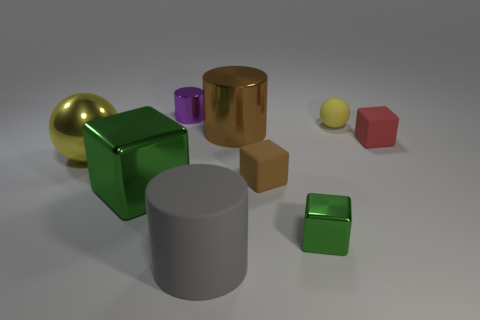Do the red cube and the big gray object have the same material?
Offer a terse response. Yes. What material is the block that is to the right of the yellow sphere that is to the right of the big cylinder that is behind the big gray rubber object made of?
Offer a terse response. Rubber. What color is the large rubber cylinder?
Keep it short and to the point. Gray. How many large things are gray things or red objects?
Offer a terse response. 1. There is a small cube that is the same color as the big cube; what is it made of?
Your answer should be very brief. Metal. Do the green object to the right of the purple metal thing and the red object right of the big gray object have the same material?
Keep it short and to the point. No. Are there any red matte blocks?
Make the answer very short. Yes. Are there more big gray cylinders that are to the left of the small red cube than small brown matte things that are behind the yellow metal ball?
Provide a succinct answer. Yes. There is a gray thing that is the same shape as the big brown thing; what is it made of?
Provide a short and direct response. Rubber. There is a small rubber object in front of the red object; is its color the same as the metal cylinder in front of the small yellow ball?
Give a very brief answer. Yes. 